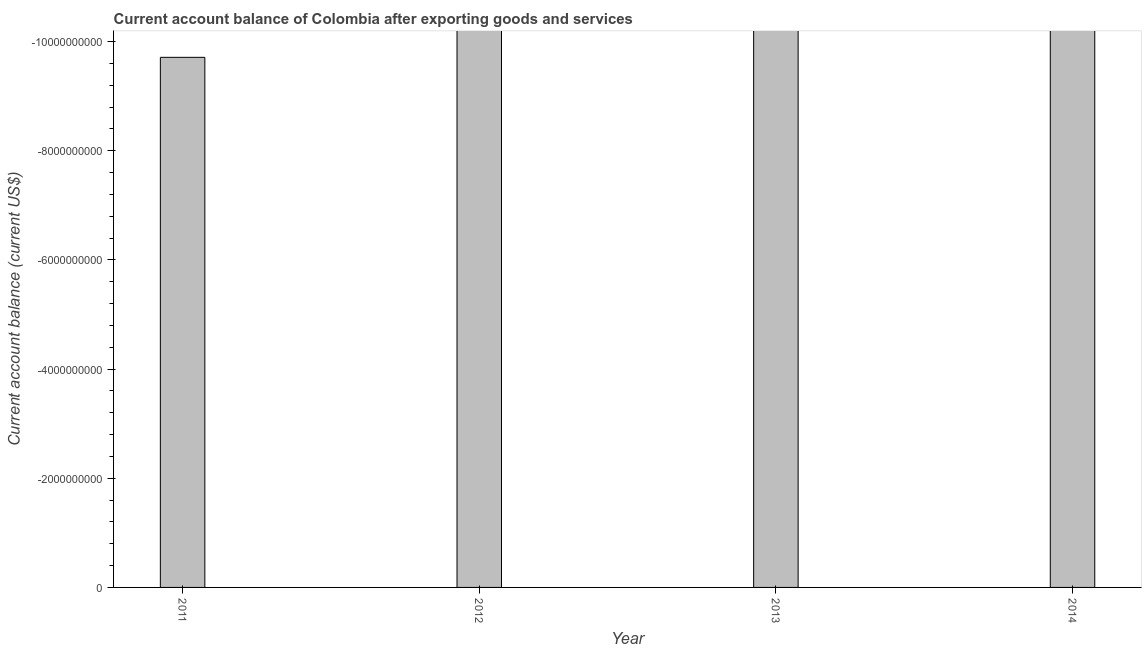What is the title of the graph?
Offer a terse response. Current account balance of Colombia after exporting goods and services. What is the label or title of the X-axis?
Your answer should be compact. Year. What is the label or title of the Y-axis?
Keep it short and to the point. Current account balance (current US$). Across all years, what is the minimum current account balance?
Your answer should be compact. 0. What is the sum of the current account balance?
Your answer should be compact. 0. What is the average current account balance per year?
Offer a very short reply. 0. What is the median current account balance?
Provide a succinct answer. 0. In how many years, is the current account balance greater than -800000000 US$?
Provide a succinct answer. 0. In how many years, is the current account balance greater than the average current account balance taken over all years?
Give a very brief answer. 0. How many bars are there?
Provide a short and direct response. 0. How many years are there in the graph?
Ensure brevity in your answer.  4. What is the difference between two consecutive major ticks on the Y-axis?
Offer a very short reply. 2.00e+09. Are the values on the major ticks of Y-axis written in scientific E-notation?
Offer a terse response. No. What is the Current account balance (current US$) of 2013?
Provide a short and direct response. 0. What is the Current account balance (current US$) of 2014?
Offer a very short reply. 0. 